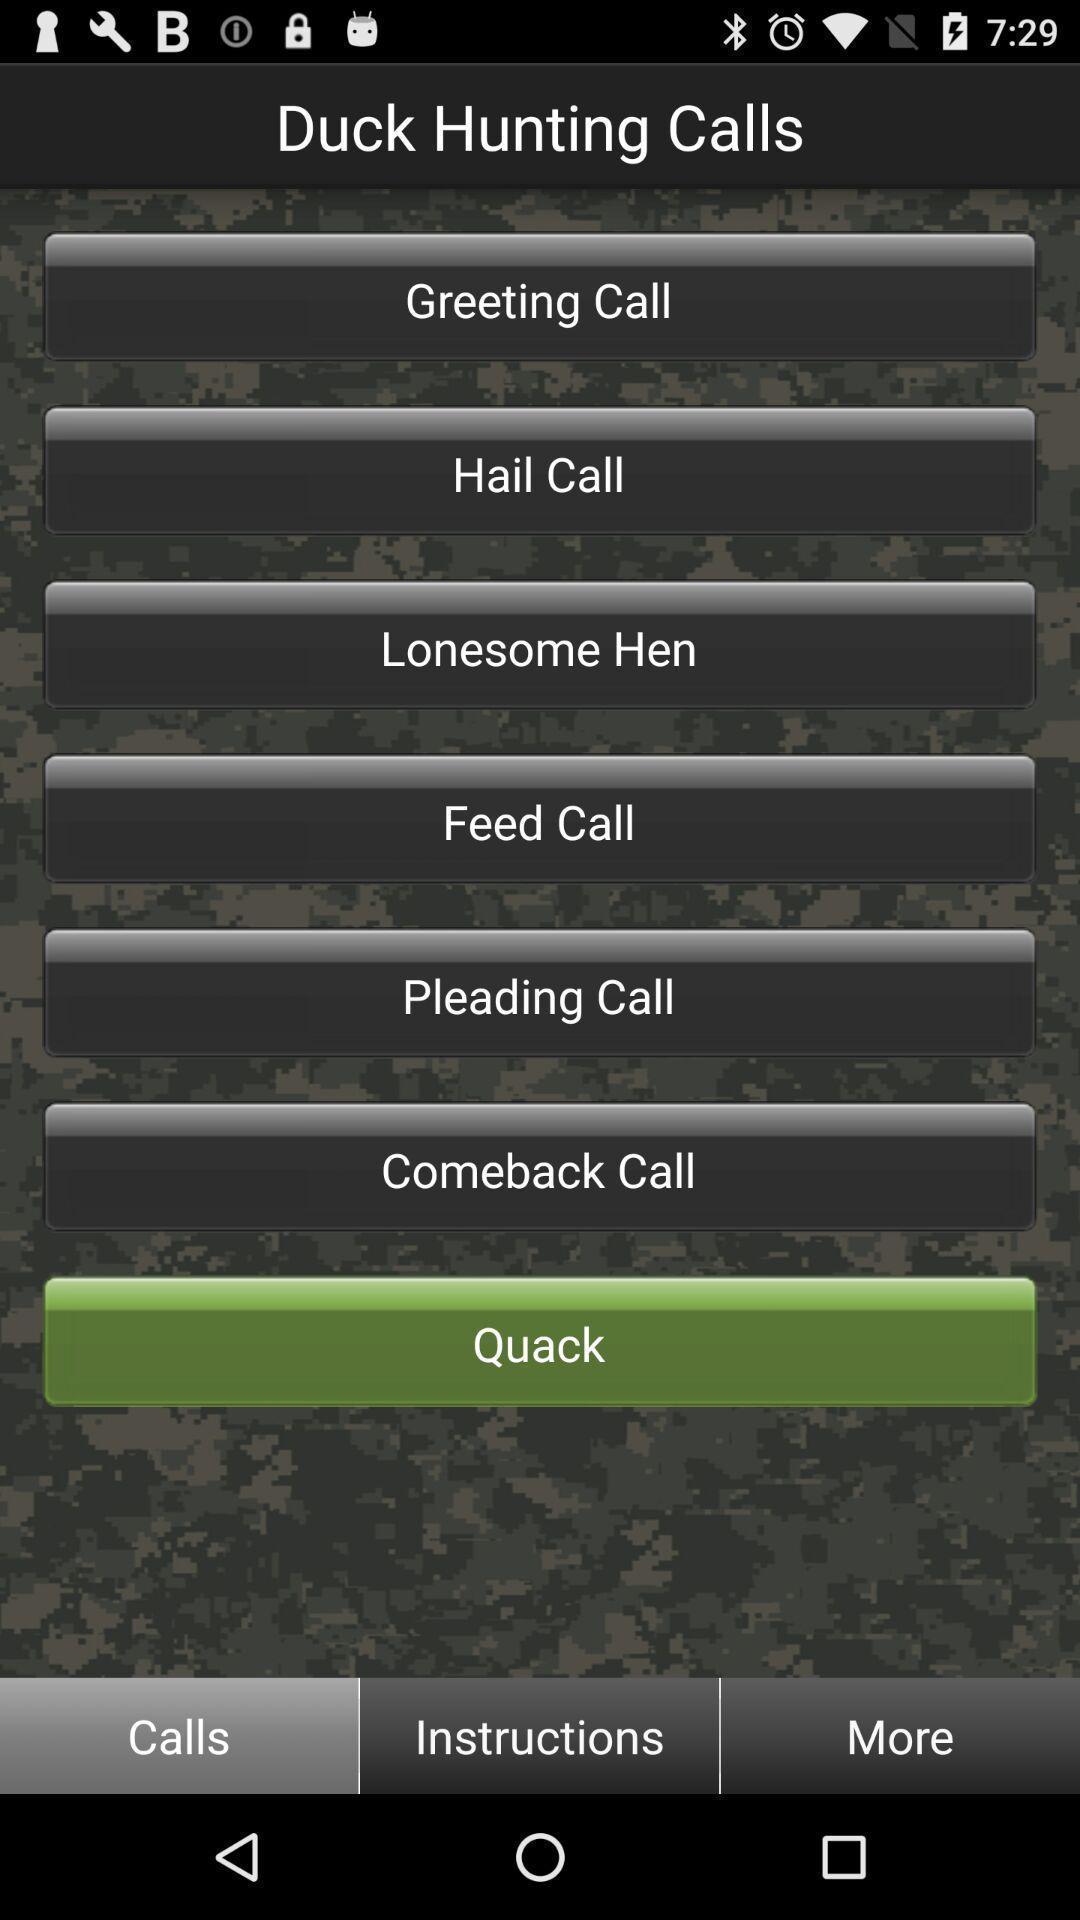Describe this image in words. Page showing the options in calling app. 